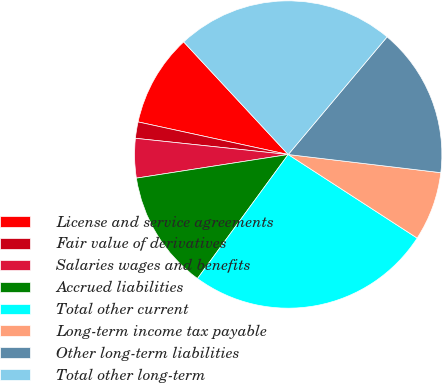Convert chart to OTSL. <chart><loc_0><loc_0><loc_500><loc_500><pie_chart><fcel>License and service agreements<fcel>Fair value of derivatives<fcel>Salaries wages and benefits<fcel>Accrued liabilities<fcel>Total other current<fcel>Long-term income tax payable<fcel>Other long-term liabilities<fcel>Total other long-term<nl><fcel>9.69%<fcel>1.72%<fcel>4.14%<fcel>12.49%<fcel>25.9%<fcel>7.27%<fcel>15.76%<fcel>23.03%<nl></chart> 